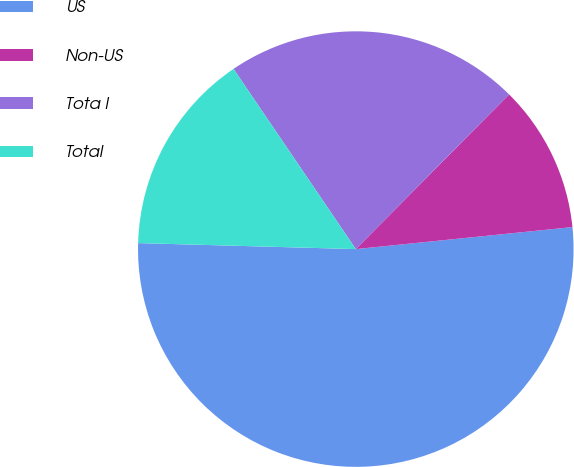Convert chart to OTSL. <chart><loc_0><loc_0><loc_500><loc_500><pie_chart><fcel>US<fcel>Non-US<fcel>Tota l<fcel>Total<nl><fcel>52.05%<fcel>10.96%<fcel>21.92%<fcel>15.07%<nl></chart> 